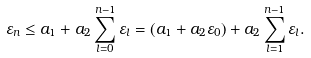Convert formula to latex. <formula><loc_0><loc_0><loc_500><loc_500>\varepsilon _ { n } \leq a _ { 1 } + a _ { 2 } \sum _ { l = 0 } ^ { n - 1 } \varepsilon _ { l } = ( a _ { 1 } + a _ { 2 } \varepsilon _ { 0 } ) + a _ { 2 } \sum _ { l = 1 } ^ { n - 1 } \varepsilon _ { l } .</formula> 